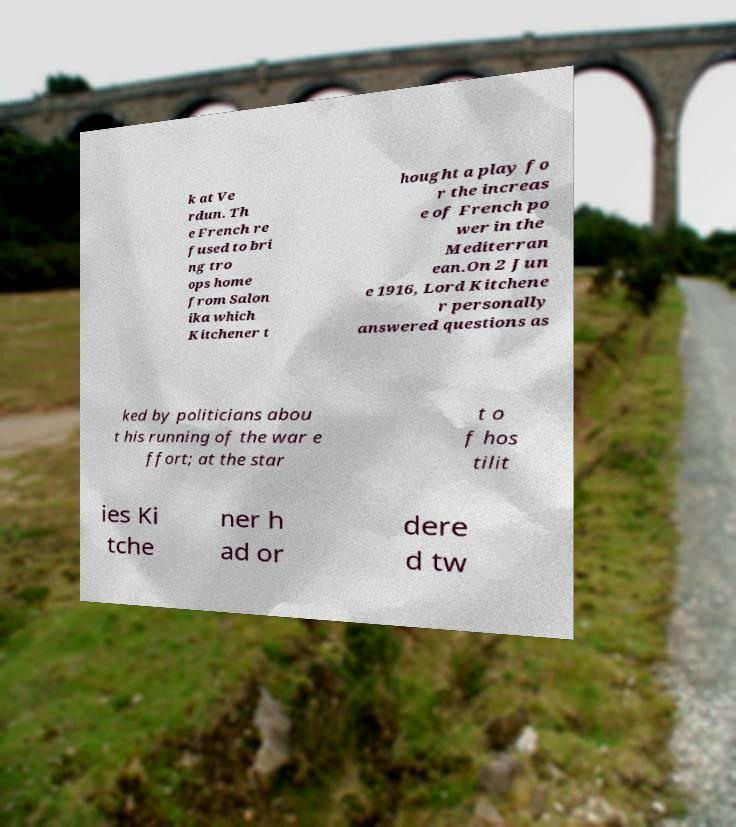Please read and relay the text visible in this image. What does it say? k at Ve rdun. Th e French re fused to bri ng tro ops home from Salon ika which Kitchener t hought a play fo r the increas e of French po wer in the Mediterran ean.On 2 Jun e 1916, Lord Kitchene r personally answered questions as ked by politicians abou t his running of the war e ffort; at the star t o f hos tilit ies Ki tche ner h ad or dere d tw 